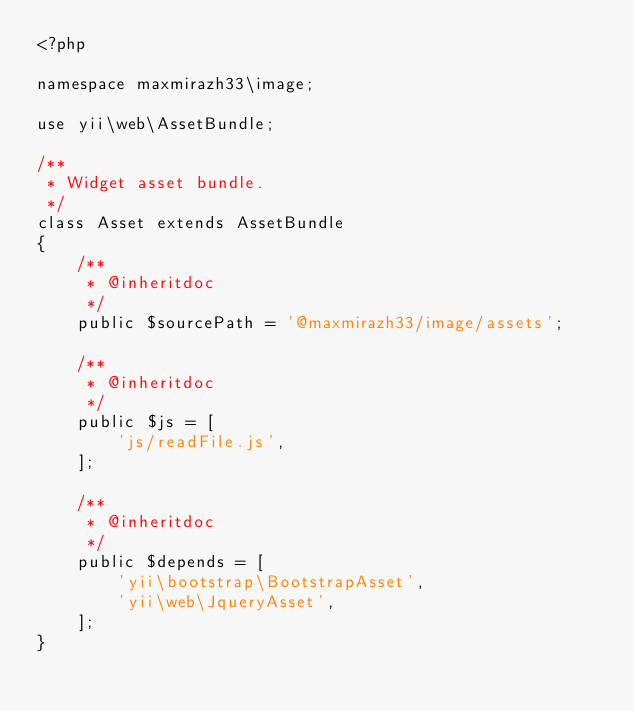Convert code to text. <code><loc_0><loc_0><loc_500><loc_500><_PHP_><?php

namespace maxmirazh33\image;

use yii\web\AssetBundle;

/**
 * Widget asset bundle.
 */
class Asset extends AssetBundle
{
    /**
     * @inheritdoc
     */
    public $sourcePath = '@maxmirazh33/image/assets';

    /**
     * @inheritdoc
     */
    public $js = [
        'js/readFile.js',
    ];

    /**
     * @inheritdoc
     */
    public $depends = [
        'yii\bootstrap\BootstrapAsset',
        'yii\web\JqueryAsset',
    ];
}
</code> 